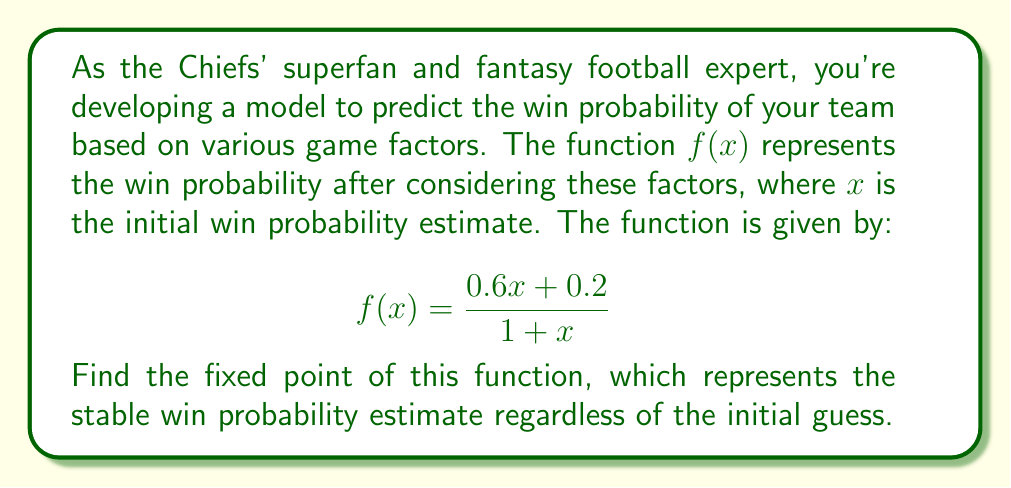Show me your answer to this math problem. Let's approach this step-by-step:

1) A fixed point of a function $f(x)$ is a value of $x$ where $f(x) = x$. So, we need to solve the equation:

   $$x = \frac{0.6x + 0.2}{1 + x}$$

2) Multiply both sides by $(1 + x)$:

   $$x(1 + x) = 0.6x + 0.2$$

3) Expand the left side:

   $$x + x^2 = 0.6x + 0.2$$

4) Rearrange the terms to standard quadratic form:

   $$x^2 + 0.4x - 0.2 = 0$$

5) Use the quadratic formula $x = \frac{-b \pm \sqrt{b^2 - 4ac}}{2a}$, where $a = 1$, $b = 0.4$, and $c = -0.2$:

   $$x = \frac{-0.4 \pm \sqrt{0.4^2 - 4(1)(-0.2)}}{2(1)}$$

6) Simplify:

   $$x = \frac{-0.4 \pm \sqrt{0.16 + 0.8}}{2} = \frac{-0.4 \pm \sqrt{0.96}}{2} = \frac{-0.4 \pm 0.98}{2}$$

7) This gives us two solutions:

   $$x_1 = \frac{-0.4 + 0.98}{2} = 0.29$$
   $$x_2 = \frac{-0.4 - 0.98}{2} = -0.69$$

8) Since we're dealing with probabilities, we can discard the negative solution. Therefore, the fixed point is 0.29.
Answer: 0.29 